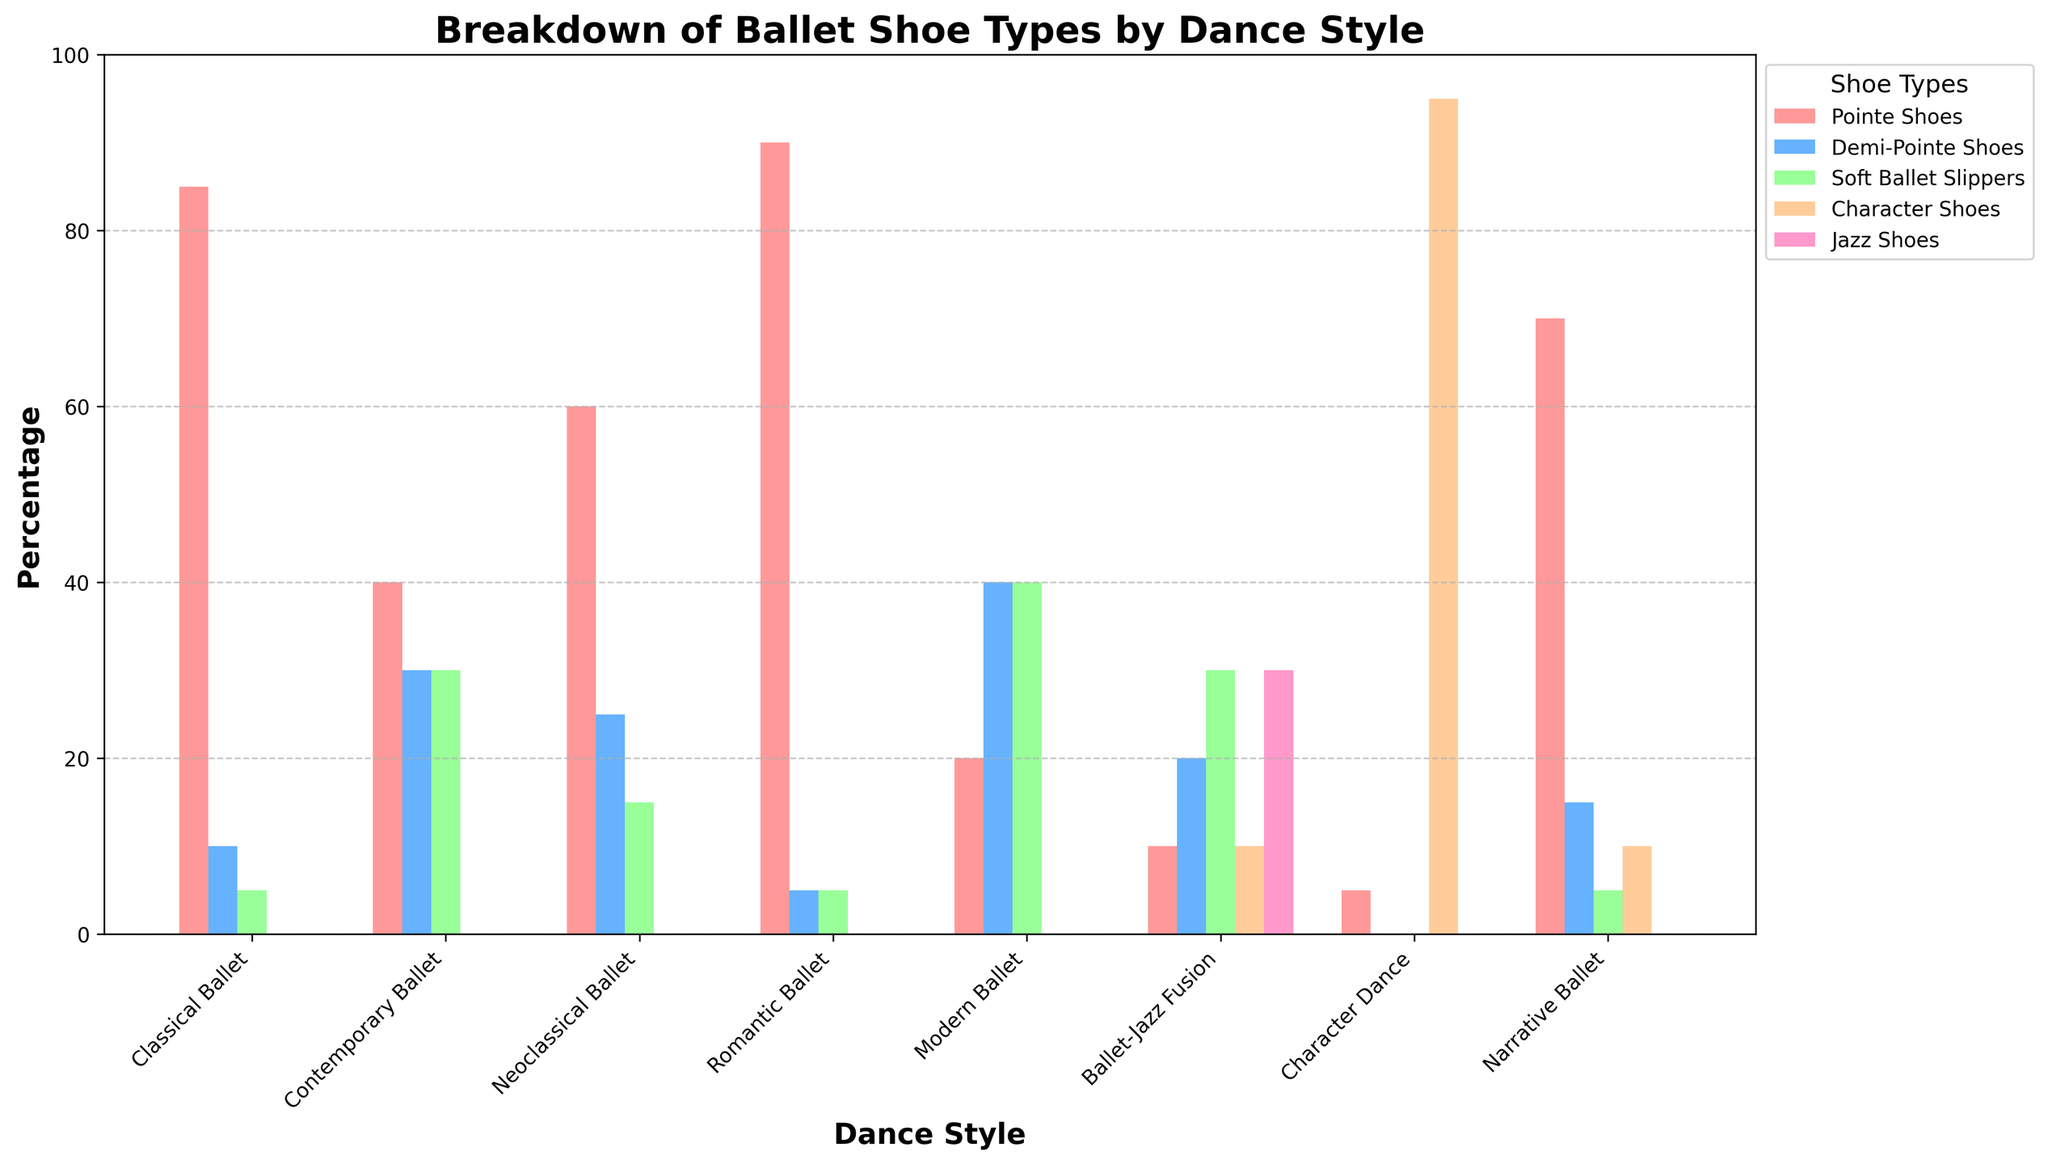What is the most commonly used shoe type in Classical Ballet? Look at the bar corresponding to "Classical Ballet" and identify the tallest bar. The tallest bar represents Pointe Shoes.
Answer: Pointe Shoes Which dance style uses Character Shoes the most? Find the dance style with the tallest bar in the Character Shoes category. The tallest bar is for Character Dance.
Answer: Character Dance What is the difference between the percentage of Pointe Shoes used in Classical Ballet and Romantic Ballet? For Classical Ballet, the percentage is 85. For Romantic Ballet, the percentage is 90. The difference is 90 - 85.
Answer: 5 Is there a dance style where Pointe Shoes are used but Character Shoes are not? Compare the bars for all styles. Classical Ballet, Contemporary Ballet, Neoclassical Ballet, Romantic Ballet, Modern Ballet, and Narrative Ballet use Pointe Shoes without Character Shoes.
Answer: Yes Which dance style has the most even distribution of shoe types? Observe the bars for each dance style and identify the one with the closest heights. Contemporary Ballet and Modern Ballet have even distributions.
Answer: Contemporary Ballet or Modern Ballet How many more percentage of Soft Ballet Slippers are used in Ballet-Jazz Fusion compared to Romantic Ballet? Ballet-Jazz Fusion uses 30% Soft Ballet Slippers, and Romantic Ballet uses 5%. The difference is 30 - 5.
Answer: 25 Which shoe type is predominantly used in Modern Ballet? The tallest bar for Modern Ballet represents Soft Ballet Slippers, indicating their predominant use.
Answer: Soft Ballet Slippers Calculate the total percentage of Jazz Shoes used across all dance styles. Only Ballet-Jazz Fusion uses Jazz Shoes at 30%. Therefore, the total is simply 30.
Answer: 30 Which dance style uses the least amount of Pointe Shoes? Compare the height of the bars for Pointe Shoes category across all dance styles. Ballet-Jazz Fusion and Character Dance use the least at 10% and 5%, respectively, but less than Pointe.
Answer: Character Dance Between Contemporary Ballet and Neoclassical Ballet, which style uses more Demi-Pointe Shoes? The bar for Contemporary Ballet is higher in the Demi-Pointe Shoes category at 30%, while Neoclassical Ballet is at 25%.
Answer: Contemporary Ballet 